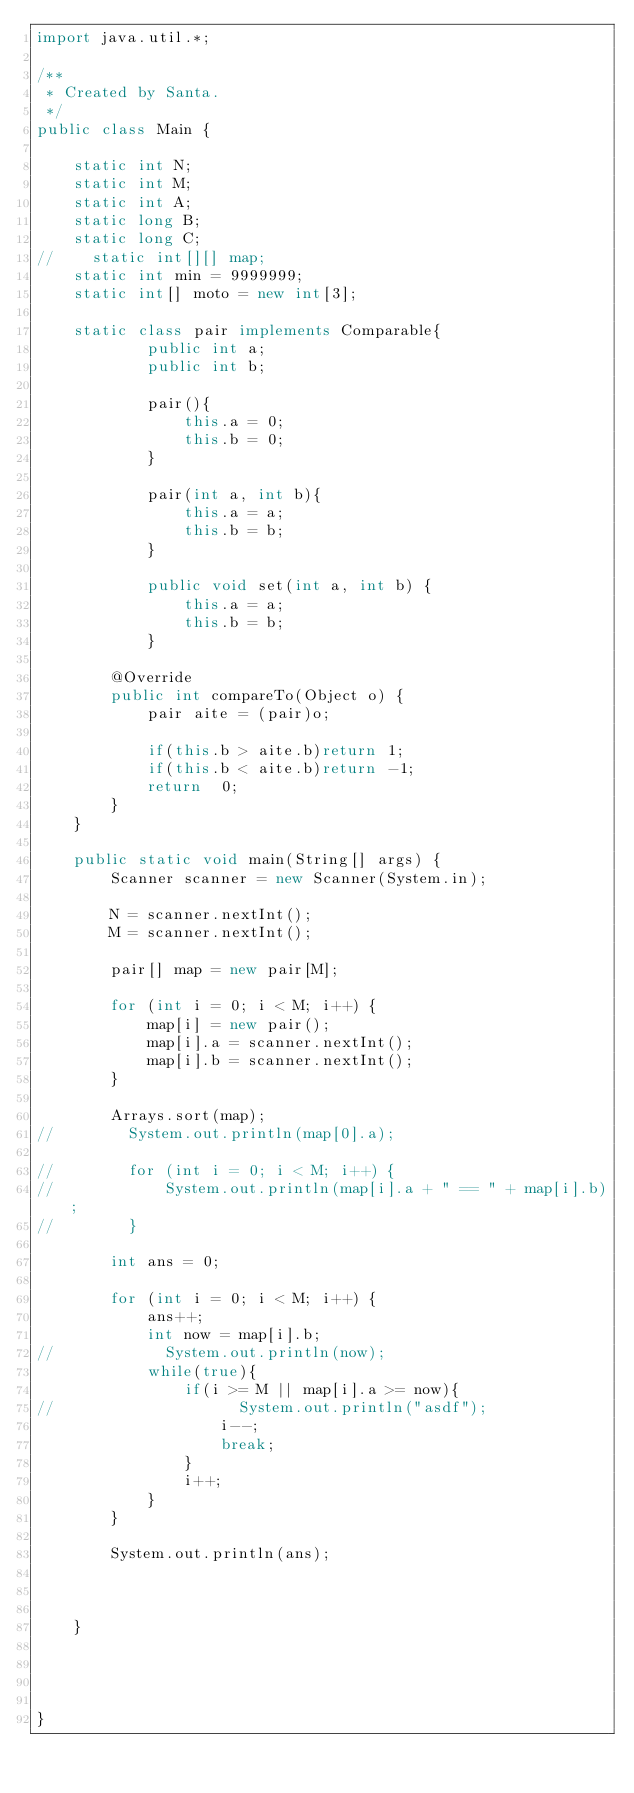Convert code to text. <code><loc_0><loc_0><loc_500><loc_500><_Java_>import java.util.*;

/**
 * Created by Santa.
 */
public class Main {

    static int N;
    static int M;
    static int A;
    static long B;
    static long C;
//    static int[][] map;
    static int min = 9999999;
    static int[] moto = new int[3];

    static class pair implements Comparable{
            public int a;
            public int b;

            pair(){
                this.a = 0;
                this.b = 0;
            }

            pair(int a, int b){
                this.a = a;
                this.b = b;
            }

            public void set(int a, int b) {
                this.a = a;
                this.b = b;
            }

        @Override
        public int compareTo(Object o) {
            pair aite = (pair)o;

            if(this.b > aite.b)return 1;
            if(this.b < aite.b)return -1;
            return  0;
        }
    }

    public static void main(String[] args) {
        Scanner scanner = new Scanner(System.in);

        N = scanner.nextInt();
        M = scanner.nextInt();

        pair[] map = new pair[M];

        for (int i = 0; i < M; i++) {
            map[i] = new pair();
            map[i].a = scanner.nextInt();
            map[i].b = scanner.nextInt();
        }

        Arrays.sort(map);
//        System.out.println(map[0].a);

//        for (int i = 0; i < M; i++) {
//            System.out.println(map[i].a + " == " + map[i].b);
//        }

        int ans = 0;

        for (int i = 0; i < M; i++) {
            ans++;
            int now = map[i].b;
//            System.out.println(now);
            while(true){
                if(i >= M || map[i].a >= now){
//                    System.out.println("asdf");
                    i--;
                    break;
                }
                i++;
            }
        }

        System.out.println(ans);



    }




}

</code> 